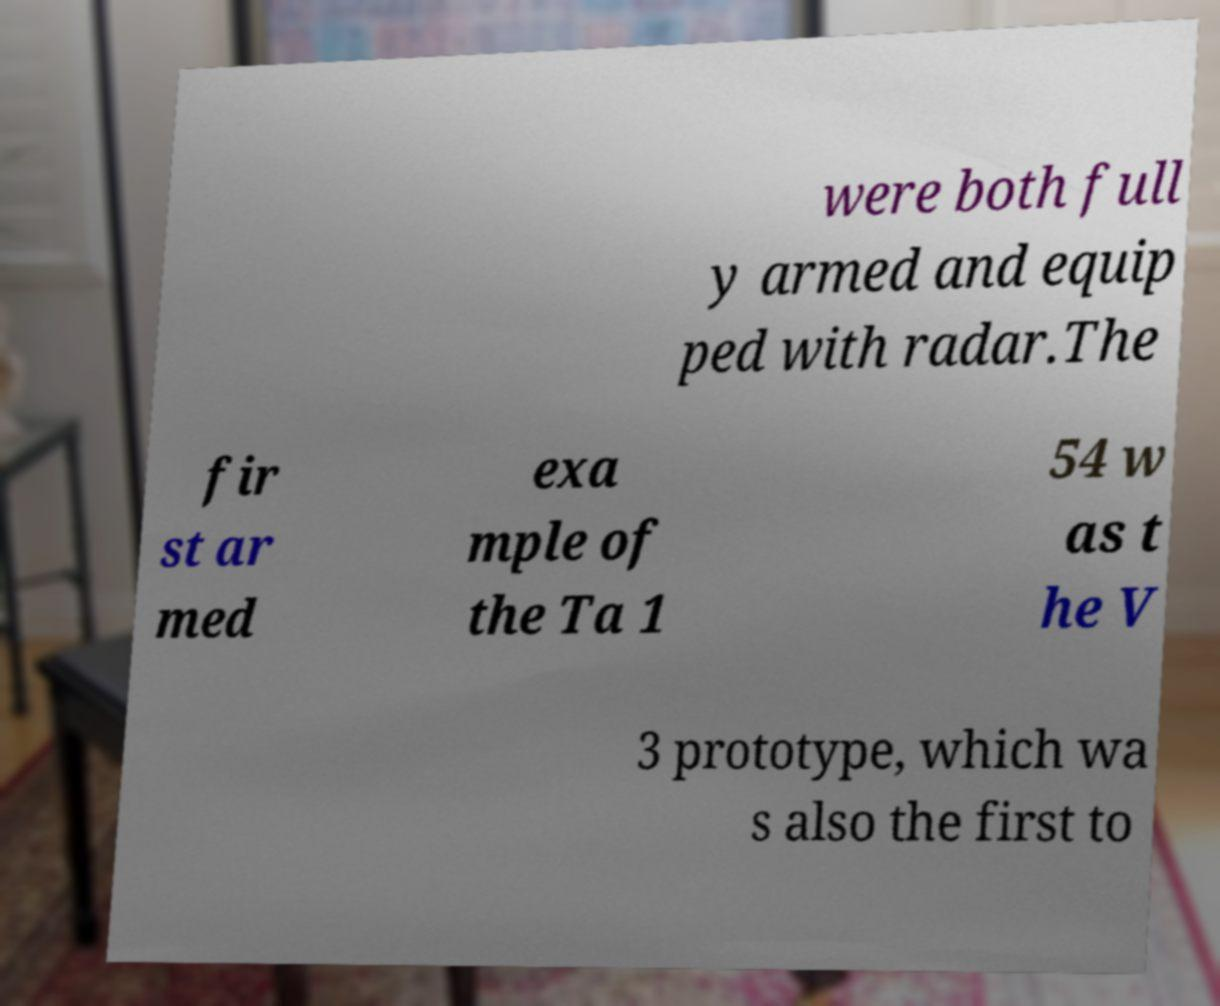Could you extract and type out the text from this image? were both full y armed and equip ped with radar.The fir st ar med exa mple of the Ta 1 54 w as t he V 3 prototype, which wa s also the first to 